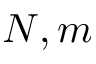<formula> <loc_0><loc_0><loc_500><loc_500>N , m</formula> 